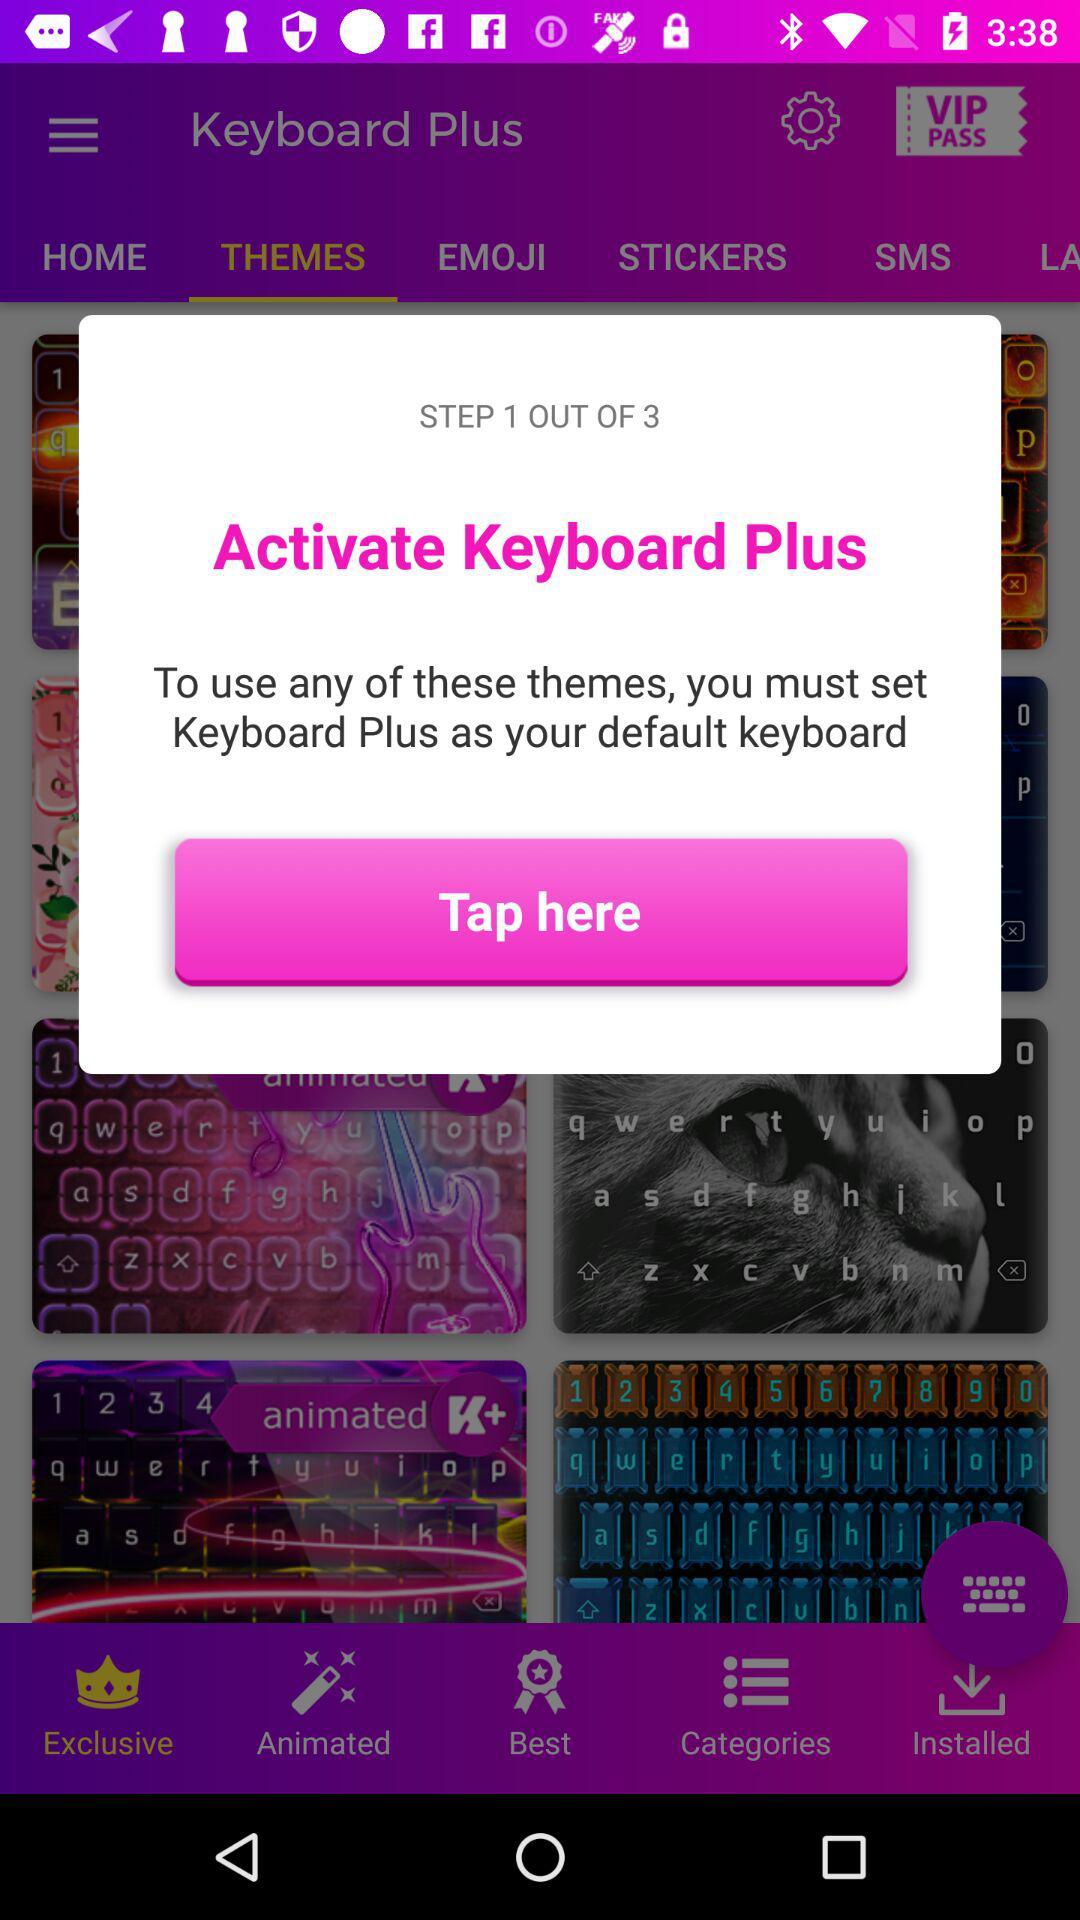How many themes are available?
When the provided information is insufficient, respond with <no answer>. <no answer> 